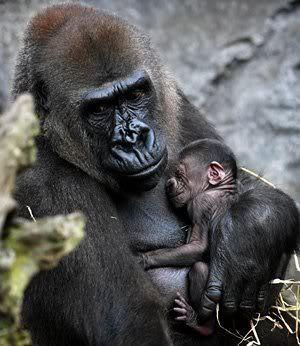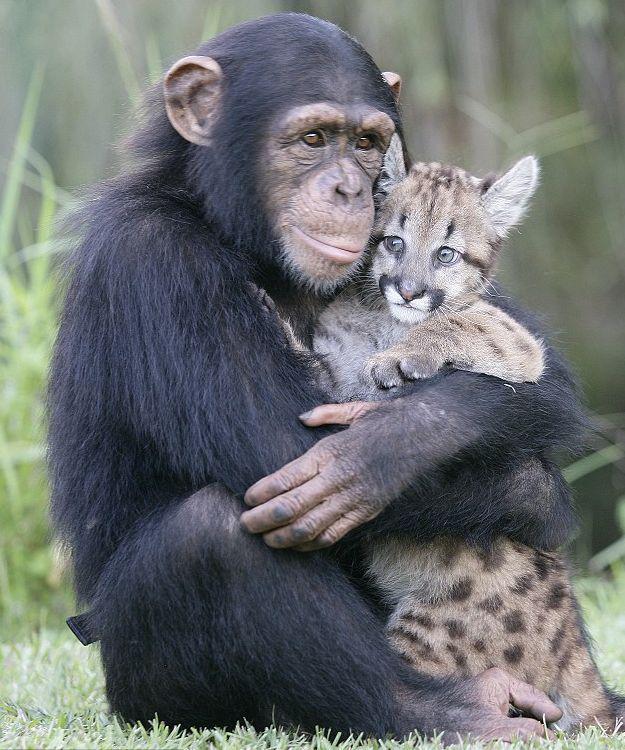The first image is the image on the left, the second image is the image on the right. For the images shown, is this caption "Each image shows a larger animal hugging a smaller one." true? Answer yes or no. Yes. 